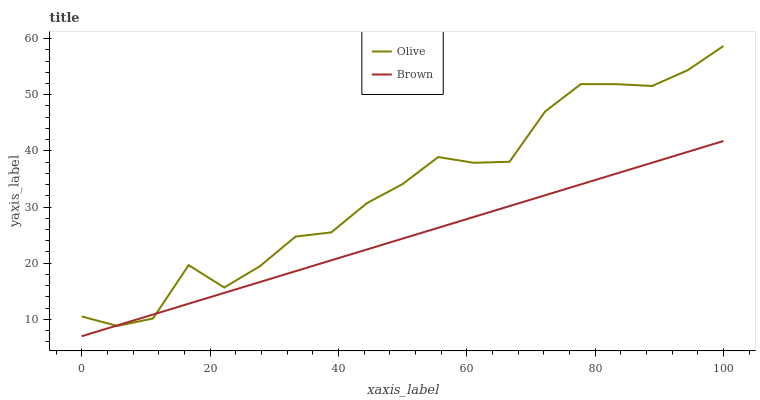Does Brown have the minimum area under the curve?
Answer yes or no. Yes. Does Olive have the maximum area under the curve?
Answer yes or no. Yes. Does Brown have the maximum area under the curve?
Answer yes or no. No. Is Brown the smoothest?
Answer yes or no. Yes. Is Olive the roughest?
Answer yes or no. Yes. Is Brown the roughest?
Answer yes or no. No. Does Brown have the lowest value?
Answer yes or no. Yes. Does Olive have the highest value?
Answer yes or no. Yes. Does Brown have the highest value?
Answer yes or no. No. Does Olive intersect Brown?
Answer yes or no. Yes. Is Olive less than Brown?
Answer yes or no. No. Is Olive greater than Brown?
Answer yes or no. No. 